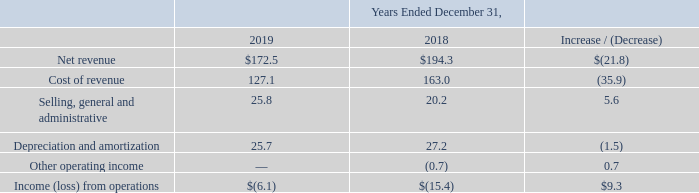Segment Results of Operations
In the Company's Consolidated Financial Statements, other operating (income) expense includes (i) (gain) loss on sale or disposal of assets, (ii) lease termination costs, (iii)
asset impairment expense, (iv) accretion of asset retirement obligations, and (v) FCC reimbursements. Each table summarizes the results of operations of our operating
segments and compares the amount of the change between the periods presented (in millions).                                Marine Services Segment
Net revenue: Net revenue from our Marine Services segment for the year ended December 31, 2019 decreased $21.8 million to $172.5 million from $194.3 million for the year ended December 31, 2018. The decrease was primarily driven by a decline in the volume of projects under execution across multiple reporting lines, including power cable repair in offshore renewables, telecom installation work, and a reduction in CWind Group revenue due to focusing on a mix of more profitable projects.
Cost of revenue: Cost of revenue from our Marine Services segment for the year ended December 31, 2019 decreased $35.9 million to $127.1 million from $163.0 million for the year ended December 31, 2018. The decrease was driven by the reduction in revenue, improved vessel utilization, and higher than expected costs on a certain power construction project in the comparable period that were not repeated.
Selling, general and administrative: Selling, general and administrative expenses from our Marine Services segment for the year ended December 31, 2019 increased $5.6 million to $25.8 million from $20.2 million for the year ended December 31, 2018. The increase was primarily due to higher disposition costs in the fourth quarter of 2019 related to the sale of the Marine Services segment. This was partially offset by a reversal of an accrual of bad debt expense in the current period due to a favorable receivable settlement during the quarter. See Note 24. Subsequent Events for the summary of the subsequent events.
Depreciation and amortization: Depreciation and amortization from our Marine Services segment for the year ended December 31, 2019 decreased $1.5 million to $25.7 million from $27.2 million for the year ended December 31, 2018. The decrease was largely attributable to the disposal of assets during the year.
Other operating income: Other operating income decreased $0.7 million from $0.7 million of income for the year ended December 31, 2018, as a result of an impairment expense recorded in 2019 due to the under-utilization of assets on one of the segment's barges.
What was the net revenue from Marine Services segment for the year ended December 31, 2019? $172.5 million. What was the net revenue from Marine Services segment for the year ended December 31, 2018? $194.3 million. What was the cost of revenue from Marine Services segment for the year ended December 31, 2019? $127.1 million. What was the percentage increase / (decrease) in the net revenue from 2018 to 2019?
Answer scale should be: percent. 172.5 / 194.3 - 1
Answer: -11.22. What was the average cost of revenue?
Answer scale should be: million. (127.1 + 163.0) / 2
Answer: 145.05. What is the percentage increase / (decrease) in the Depreciation and amortization from 2018 to 2019?
Answer scale should be: percent. 25.7 / 27.2 - 1
Answer: -5.51. 